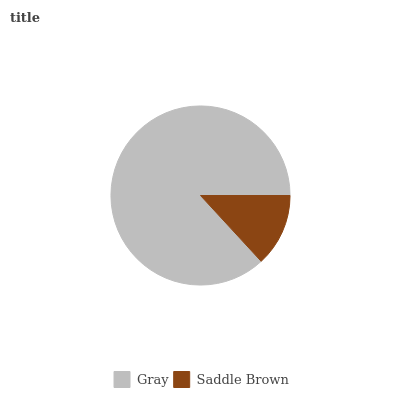Is Saddle Brown the minimum?
Answer yes or no. Yes. Is Gray the maximum?
Answer yes or no. Yes. Is Saddle Brown the maximum?
Answer yes or no. No. Is Gray greater than Saddle Brown?
Answer yes or no. Yes. Is Saddle Brown less than Gray?
Answer yes or no. Yes. Is Saddle Brown greater than Gray?
Answer yes or no. No. Is Gray less than Saddle Brown?
Answer yes or no. No. Is Gray the high median?
Answer yes or no. Yes. Is Saddle Brown the low median?
Answer yes or no. Yes. Is Saddle Brown the high median?
Answer yes or no. No. Is Gray the low median?
Answer yes or no. No. 